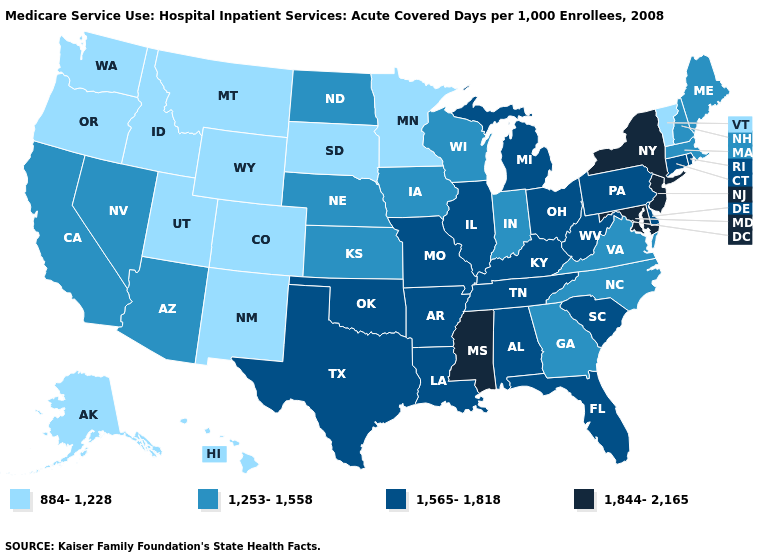How many symbols are there in the legend?
Be succinct. 4. Does Missouri have the lowest value in the MidWest?
Answer briefly. No. Is the legend a continuous bar?
Keep it brief. No. What is the highest value in the USA?
Answer briefly. 1,844-2,165. What is the value of South Dakota?
Short answer required. 884-1,228. Name the states that have a value in the range 1,844-2,165?
Answer briefly. Maryland, Mississippi, New Jersey, New York. Name the states that have a value in the range 1,253-1,558?
Concise answer only. Arizona, California, Georgia, Indiana, Iowa, Kansas, Maine, Massachusetts, Nebraska, Nevada, New Hampshire, North Carolina, North Dakota, Virginia, Wisconsin. What is the lowest value in the Northeast?
Short answer required. 884-1,228. What is the value of Arizona?
Write a very short answer. 1,253-1,558. Does Utah have the lowest value in the USA?
Concise answer only. Yes. Which states have the lowest value in the USA?
Answer briefly. Alaska, Colorado, Hawaii, Idaho, Minnesota, Montana, New Mexico, Oregon, South Dakota, Utah, Vermont, Washington, Wyoming. Among the states that border Connecticut , does Massachusetts have the highest value?
Quick response, please. No. What is the lowest value in the MidWest?
Give a very brief answer. 884-1,228. Name the states that have a value in the range 1,565-1,818?
Be succinct. Alabama, Arkansas, Connecticut, Delaware, Florida, Illinois, Kentucky, Louisiana, Michigan, Missouri, Ohio, Oklahoma, Pennsylvania, Rhode Island, South Carolina, Tennessee, Texas, West Virginia. 